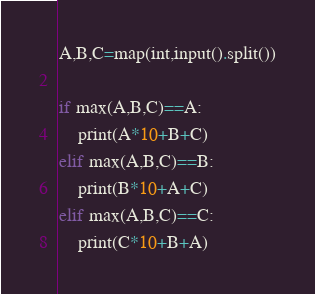<code> <loc_0><loc_0><loc_500><loc_500><_Python_>A,B,C=map(int,input().split())

if max(A,B,C)==A:
    print(A*10+B+C)
elif max(A,B,C)==B:
    print(B*10+A+C)
elif max(A,B,C)==C:
    print(C*10+B+A)</code> 